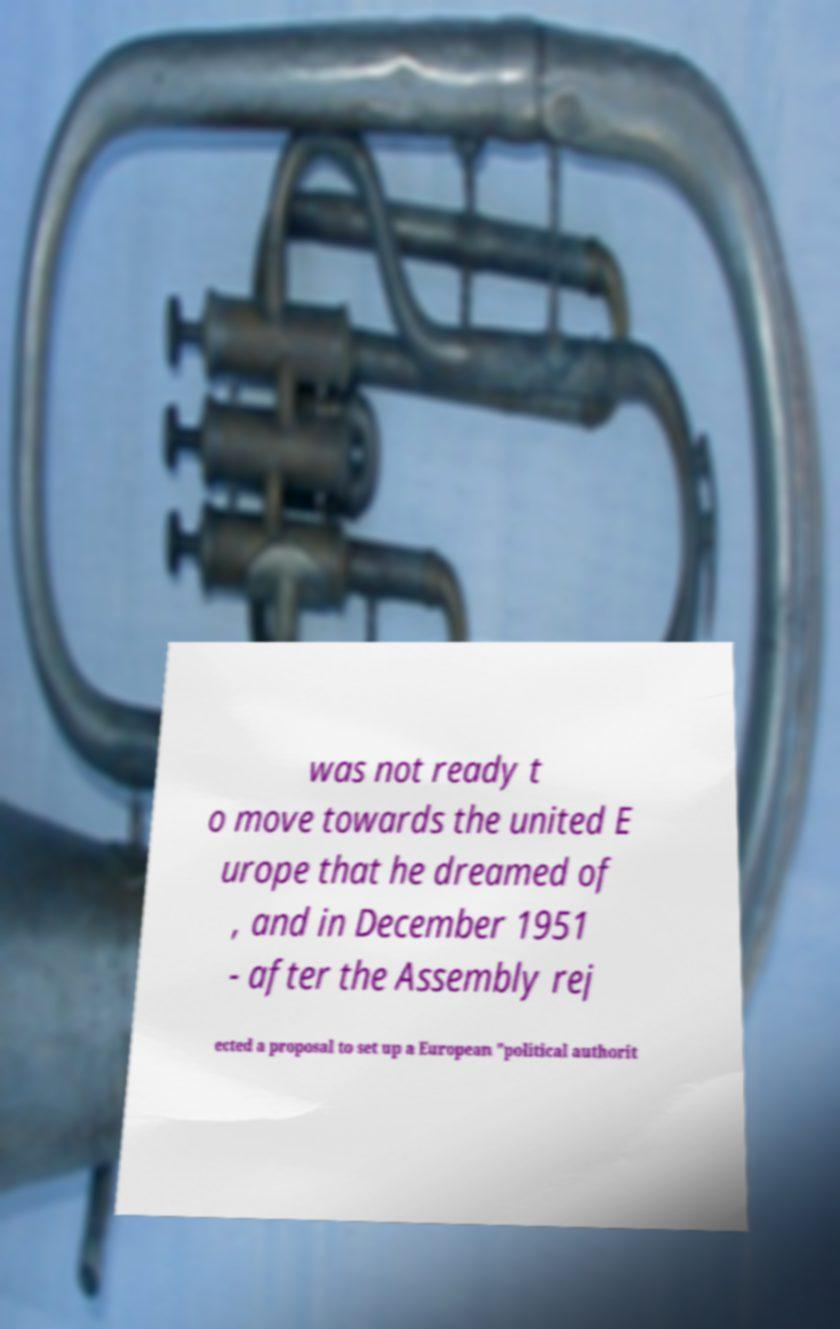Could you extract and type out the text from this image? was not ready t o move towards the united E urope that he dreamed of , and in December 1951 - after the Assembly rej ected a proposal to set up a European "political authorit 